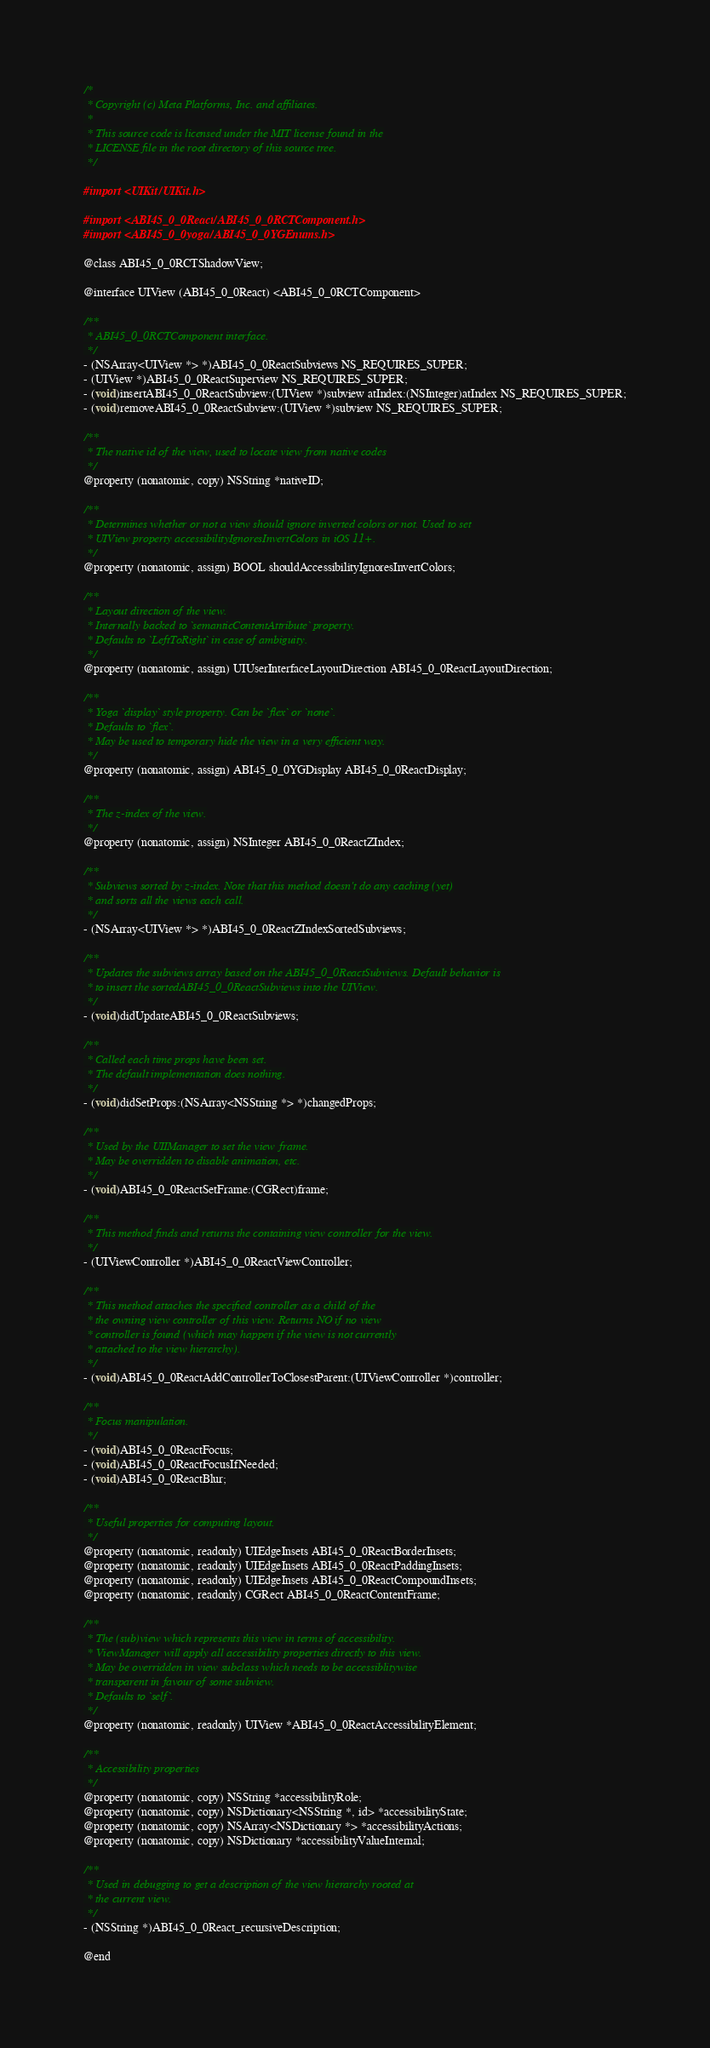<code> <loc_0><loc_0><loc_500><loc_500><_C_>/*
 * Copyright (c) Meta Platforms, Inc. and affiliates.
 *
 * This source code is licensed under the MIT license found in the
 * LICENSE file in the root directory of this source tree.
 */

#import <UIKit/UIKit.h>

#import <ABI45_0_0React/ABI45_0_0RCTComponent.h>
#import <ABI45_0_0yoga/ABI45_0_0YGEnums.h>

@class ABI45_0_0RCTShadowView;

@interface UIView (ABI45_0_0React) <ABI45_0_0RCTComponent>

/**
 * ABI45_0_0RCTComponent interface.
 */
- (NSArray<UIView *> *)ABI45_0_0ReactSubviews NS_REQUIRES_SUPER;
- (UIView *)ABI45_0_0ReactSuperview NS_REQUIRES_SUPER;
- (void)insertABI45_0_0ReactSubview:(UIView *)subview atIndex:(NSInteger)atIndex NS_REQUIRES_SUPER;
- (void)removeABI45_0_0ReactSubview:(UIView *)subview NS_REQUIRES_SUPER;

/**
 * The native id of the view, used to locate view from native codes
 */
@property (nonatomic, copy) NSString *nativeID;

/**
 * Determines whether or not a view should ignore inverted colors or not. Used to set
 * UIView property accessibilityIgnoresInvertColors in iOS 11+.
 */
@property (nonatomic, assign) BOOL shouldAccessibilityIgnoresInvertColors;

/**
 * Layout direction of the view.
 * Internally backed to `semanticContentAttribute` property.
 * Defaults to `LeftToRight` in case of ambiguity.
 */
@property (nonatomic, assign) UIUserInterfaceLayoutDirection ABI45_0_0ReactLayoutDirection;

/**
 * Yoga `display` style property. Can be `flex` or `none`.
 * Defaults to `flex`.
 * May be used to temporary hide the view in a very efficient way.
 */
@property (nonatomic, assign) ABI45_0_0YGDisplay ABI45_0_0ReactDisplay;

/**
 * The z-index of the view.
 */
@property (nonatomic, assign) NSInteger ABI45_0_0ReactZIndex;

/**
 * Subviews sorted by z-index. Note that this method doesn't do any caching (yet)
 * and sorts all the views each call.
 */
- (NSArray<UIView *> *)ABI45_0_0ReactZIndexSortedSubviews;

/**
 * Updates the subviews array based on the ABI45_0_0ReactSubviews. Default behavior is
 * to insert the sortedABI45_0_0ReactSubviews into the UIView.
 */
- (void)didUpdateABI45_0_0ReactSubviews;

/**
 * Called each time props have been set.
 * The default implementation does nothing.
 */
- (void)didSetProps:(NSArray<NSString *> *)changedProps;

/**
 * Used by the UIIManager to set the view frame.
 * May be overridden to disable animation, etc.
 */
- (void)ABI45_0_0ReactSetFrame:(CGRect)frame;

/**
 * This method finds and returns the containing view controller for the view.
 */
- (UIViewController *)ABI45_0_0ReactViewController;

/**
 * This method attaches the specified controller as a child of the
 * the owning view controller of this view. Returns NO if no view
 * controller is found (which may happen if the view is not currently
 * attached to the view hierarchy).
 */
- (void)ABI45_0_0ReactAddControllerToClosestParent:(UIViewController *)controller;

/**
 * Focus manipulation.
 */
- (void)ABI45_0_0ReactFocus;
- (void)ABI45_0_0ReactFocusIfNeeded;
- (void)ABI45_0_0ReactBlur;

/**
 * Useful properties for computing layout.
 */
@property (nonatomic, readonly) UIEdgeInsets ABI45_0_0ReactBorderInsets;
@property (nonatomic, readonly) UIEdgeInsets ABI45_0_0ReactPaddingInsets;
@property (nonatomic, readonly) UIEdgeInsets ABI45_0_0ReactCompoundInsets;
@property (nonatomic, readonly) CGRect ABI45_0_0ReactContentFrame;

/**
 * The (sub)view which represents this view in terms of accessibility.
 * ViewManager will apply all accessibility properties directly to this view.
 * May be overridden in view subclass which needs to be accessiblitywise
 * transparent in favour of some subview.
 * Defaults to `self`.
 */
@property (nonatomic, readonly) UIView *ABI45_0_0ReactAccessibilityElement;

/**
 * Accessibility properties
 */
@property (nonatomic, copy) NSString *accessibilityRole;
@property (nonatomic, copy) NSDictionary<NSString *, id> *accessibilityState;
@property (nonatomic, copy) NSArray<NSDictionary *> *accessibilityActions;
@property (nonatomic, copy) NSDictionary *accessibilityValueInternal;

/**
 * Used in debugging to get a description of the view hierarchy rooted at
 * the current view.
 */
- (NSString *)ABI45_0_0React_recursiveDescription;

@end
</code> 